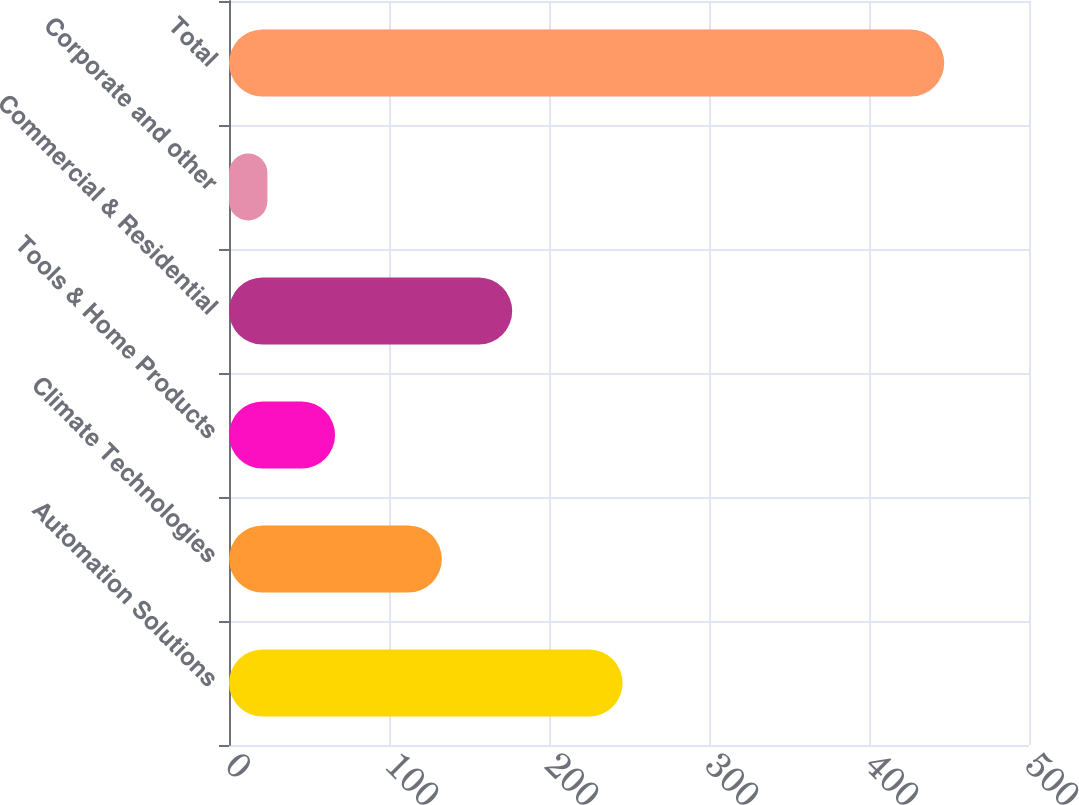Convert chart. <chart><loc_0><loc_0><loc_500><loc_500><bar_chart><fcel>Automation Solutions<fcel>Climate Technologies<fcel>Tools & Home Products<fcel>Commercial & Residential<fcel>Corporate and other<fcel>Total<nl><fcel>246<fcel>133<fcel>66.3<fcel>177<fcel>24<fcel>447<nl></chart> 